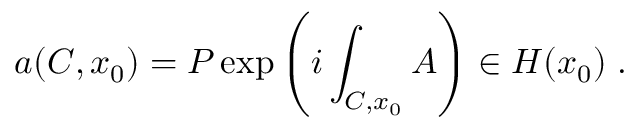<formula> <loc_0><loc_0><loc_500><loc_500>a ( C , x _ { 0 } ) = P \exp \left ( i \int _ { C , x _ { 0 } } A \right ) \in H ( x _ { 0 } ) \, .</formula> 